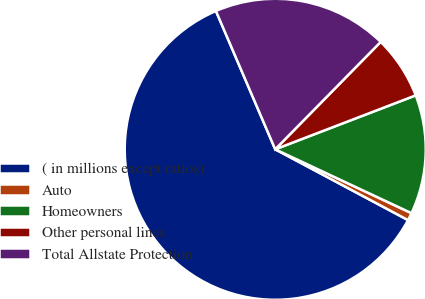Convert chart. <chart><loc_0><loc_0><loc_500><loc_500><pie_chart><fcel>( in millions except ratios)<fcel>Auto<fcel>Homeowners<fcel>Other personal lines<fcel>Total Allstate Protection<nl><fcel>60.76%<fcel>0.82%<fcel>12.81%<fcel>6.81%<fcel>18.8%<nl></chart> 